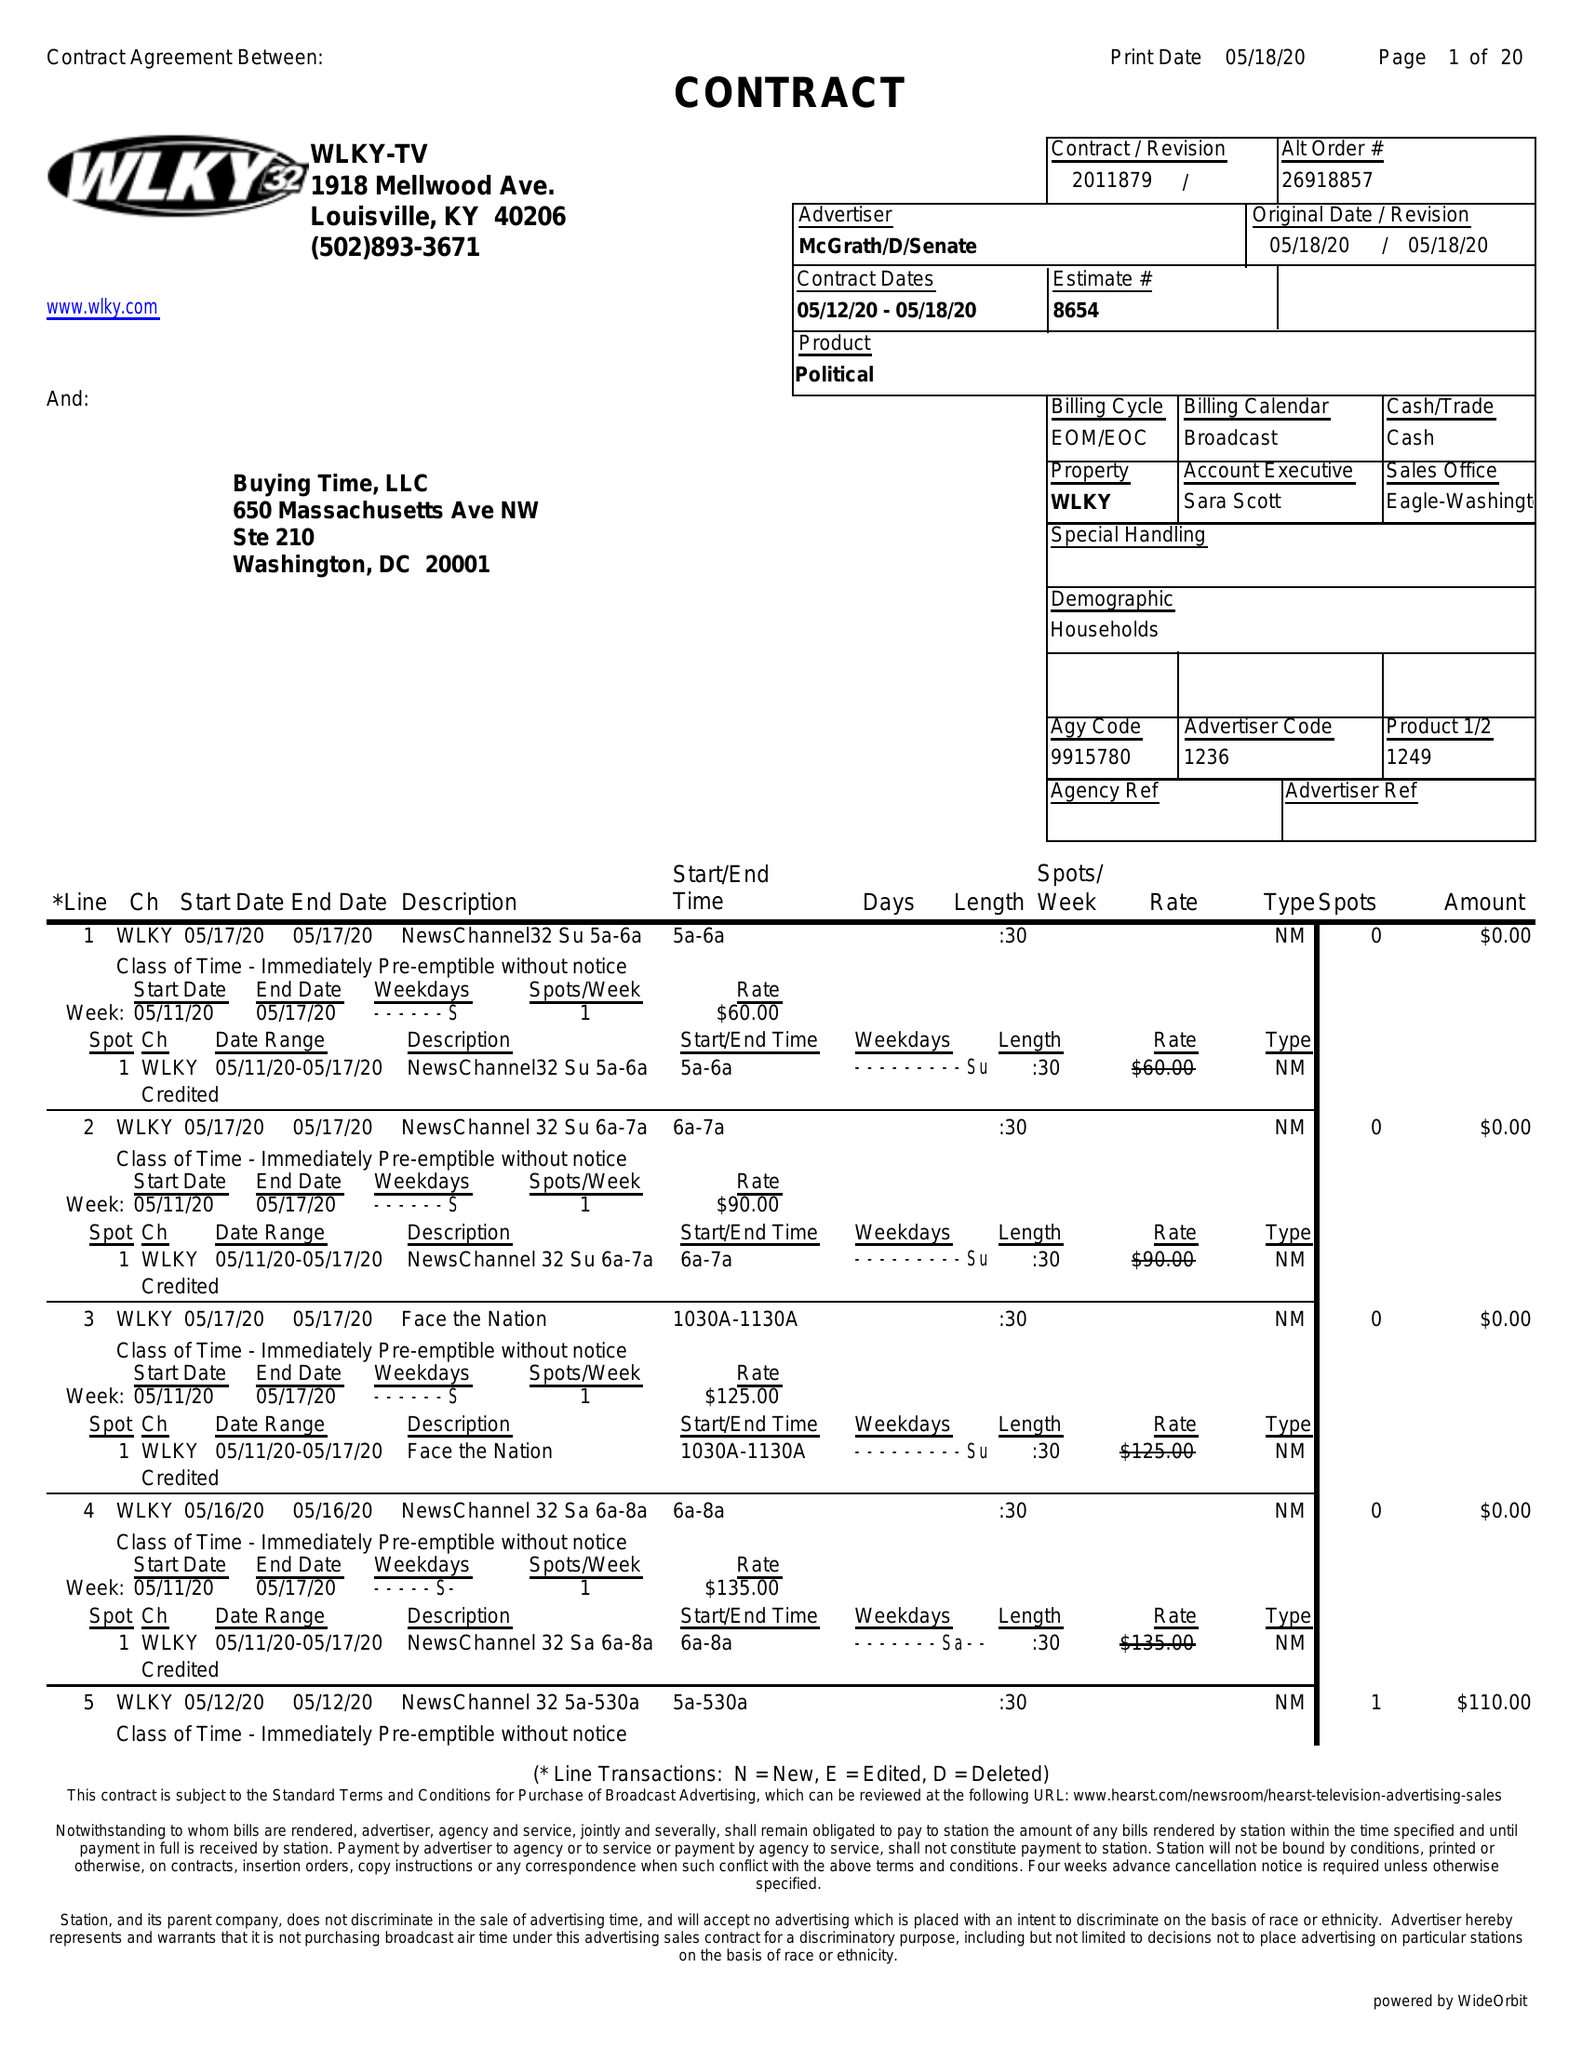What is the value for the gross_amount?
Answer the question using a single word or phrase. 25615.00 